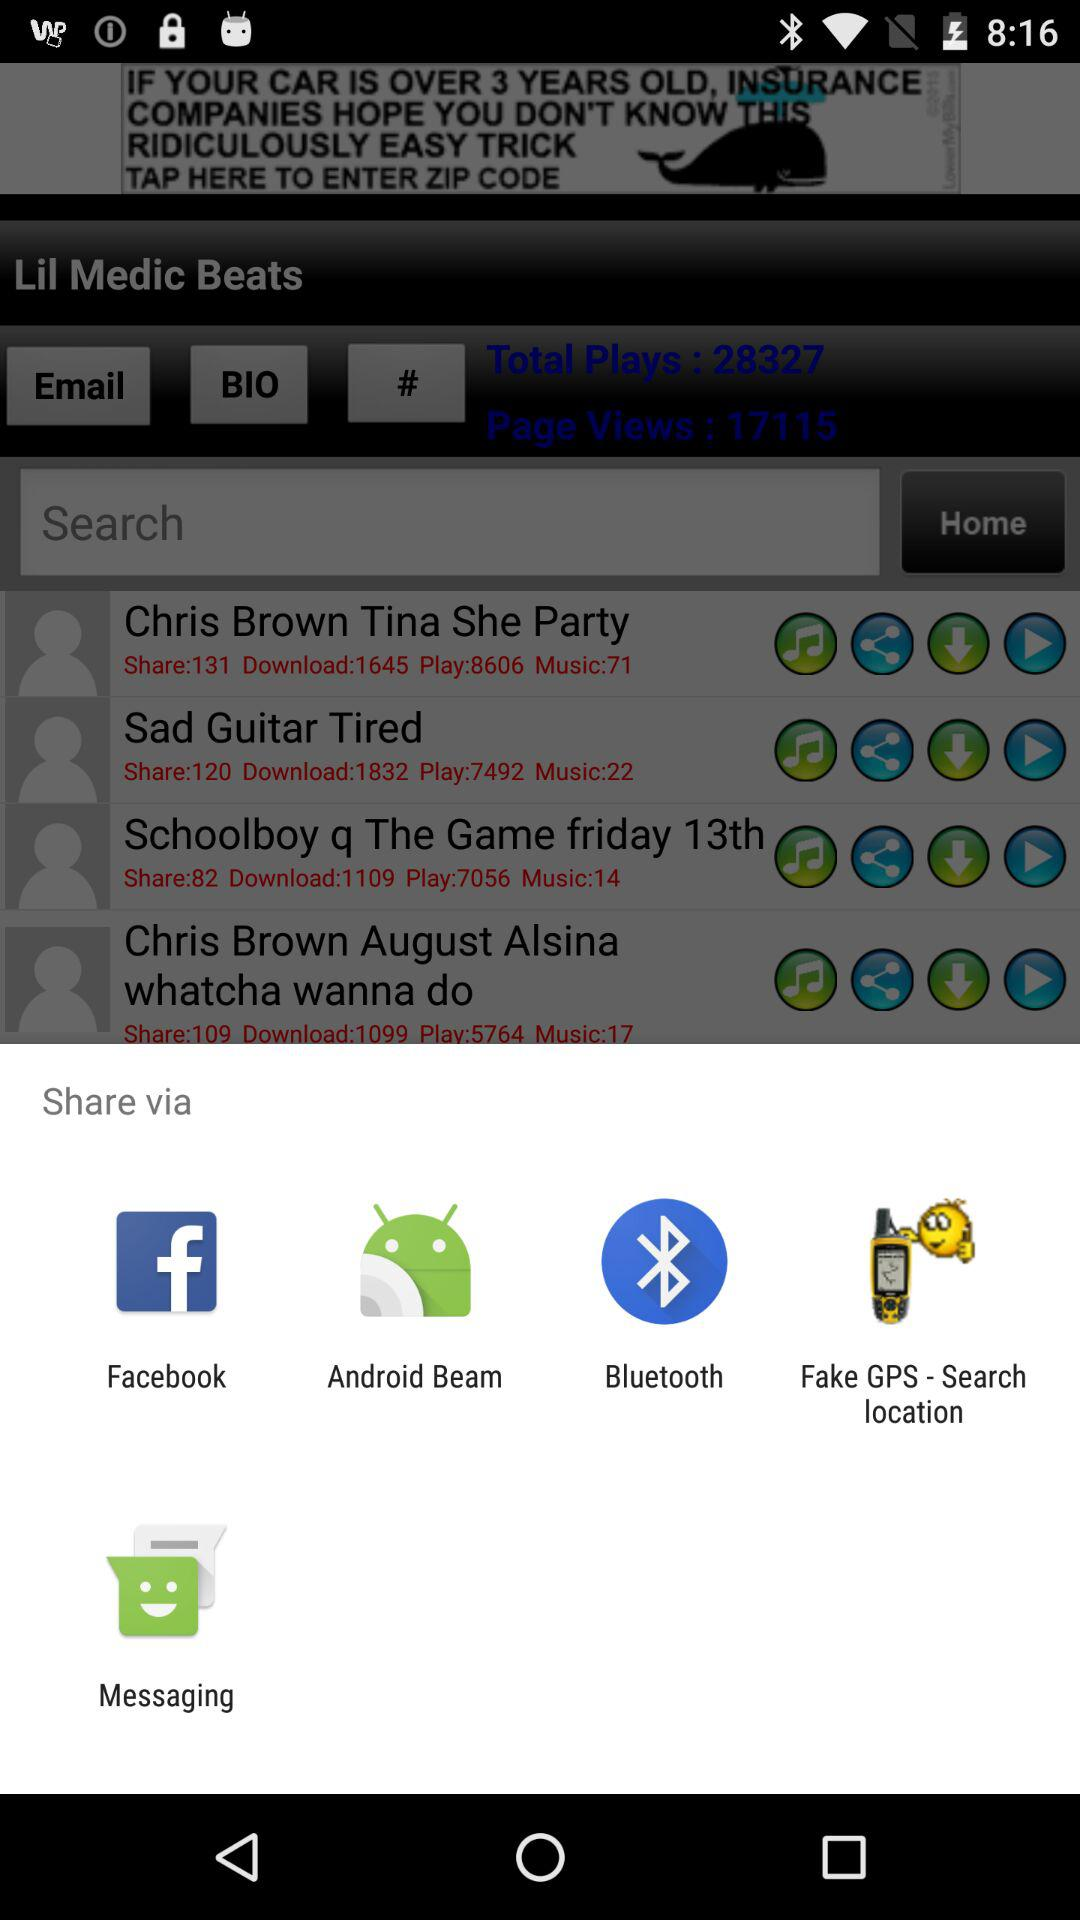Which application can be used to share? The applications that can be used to share are "Facebook", "Android Beam", "Bluetooth", "Fake GPS - Search location" and "Messaging". 